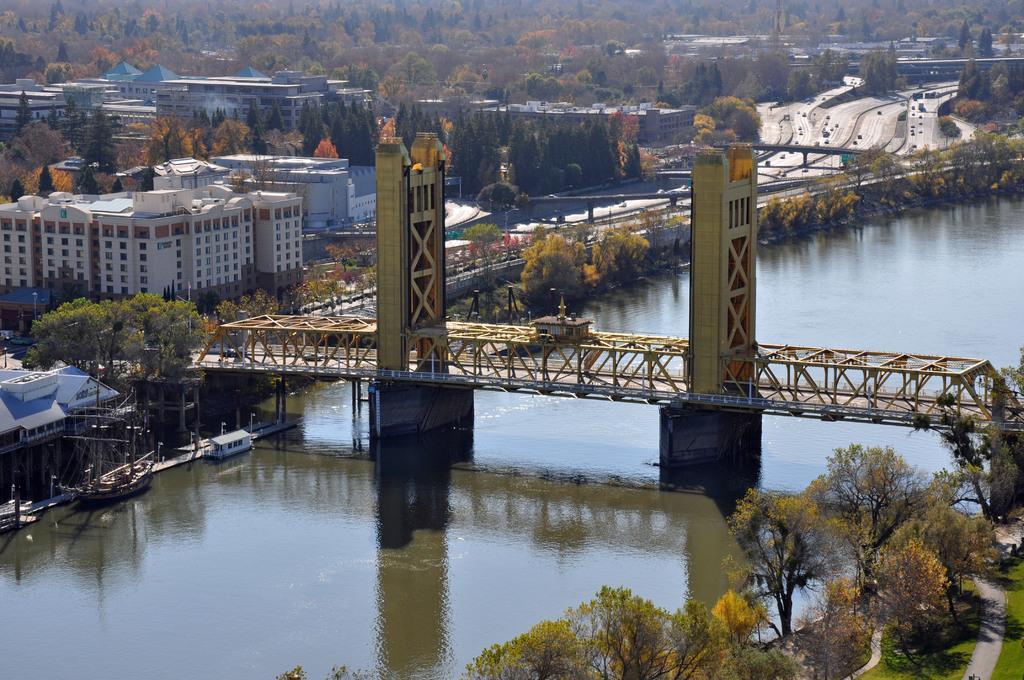Could you give a brief overview of what you see in this image? In the middle of the image we can see a metal bridge on the water. On the left side of the image we can see a group of buildings, bridges, a boot placed on the water. In the background, we can see a group of trees, 